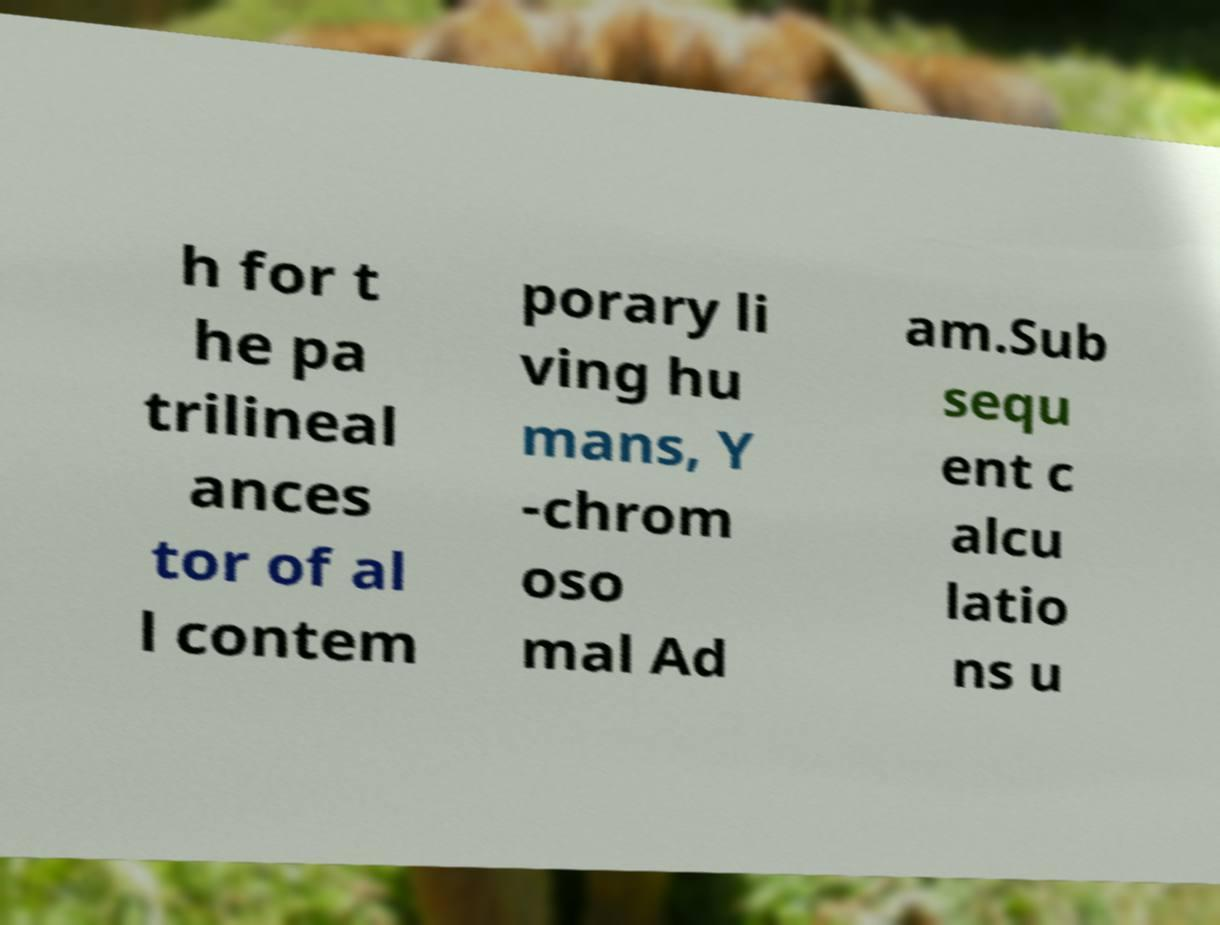What messages or text are displayed in this image? I need them in a readable, typed format. h for t he pa trilineal ances tor of al l contem porary li ving hu mans, Y -chrom oso mal Ad am.Sub sequ ent c alcu latio ns u 